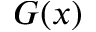Convert formula to latex. <formula><loc_0><loc_0><loc_500><loc_500>G ( x )</formula> 